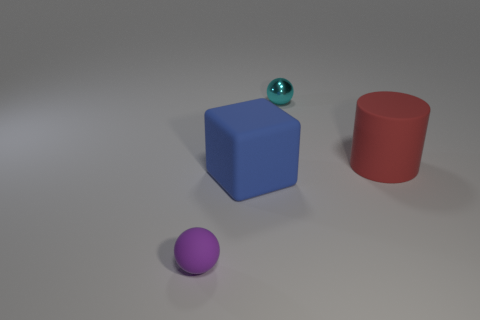Does the small sphere that is right of the purple rubber ball have the same color as the big rubber cylinder?
Your answer should be compact. No. There is a object to the right of the small ball to the right of the ball on the left side of the big blue thing; what is its material?
Your answer should be compact. Rubber. Are there any big objects that have the same color as the rubber cylinder?
Offer a very short reply. No. Are there fewer large red matte cylinders behind the large red object than small cyan spheres?
Your answer should be very brief. Yes. There is a ball behind the purple rubber sphere; does it have the same size as the rubber sphere?
Make the answer very short. Yes. What number of objects are both behind the big blue thing and on the left side of the big red rubber cylinder?
Provide a succinct answer. 1. What is the size of the rubber sphere that is left of the blue rubber block that is left of the big red cylinder?
Offer a terse response. Small. Is the number of red cylinders that are on the left side of the metallic sphere less than the number of large red things that are to the left of the big cylinder?
Give a very brief answer. No. There is a tiny ball behind the matte sphere; does it have the same color as the small thing that is in front of the big red object?
Your answer should be compact. No. There is a thing that is behind the small purple rubber thing and in front of the red matte cylinder; what material is it made of?
Keep it short and to the point. Rubber. 